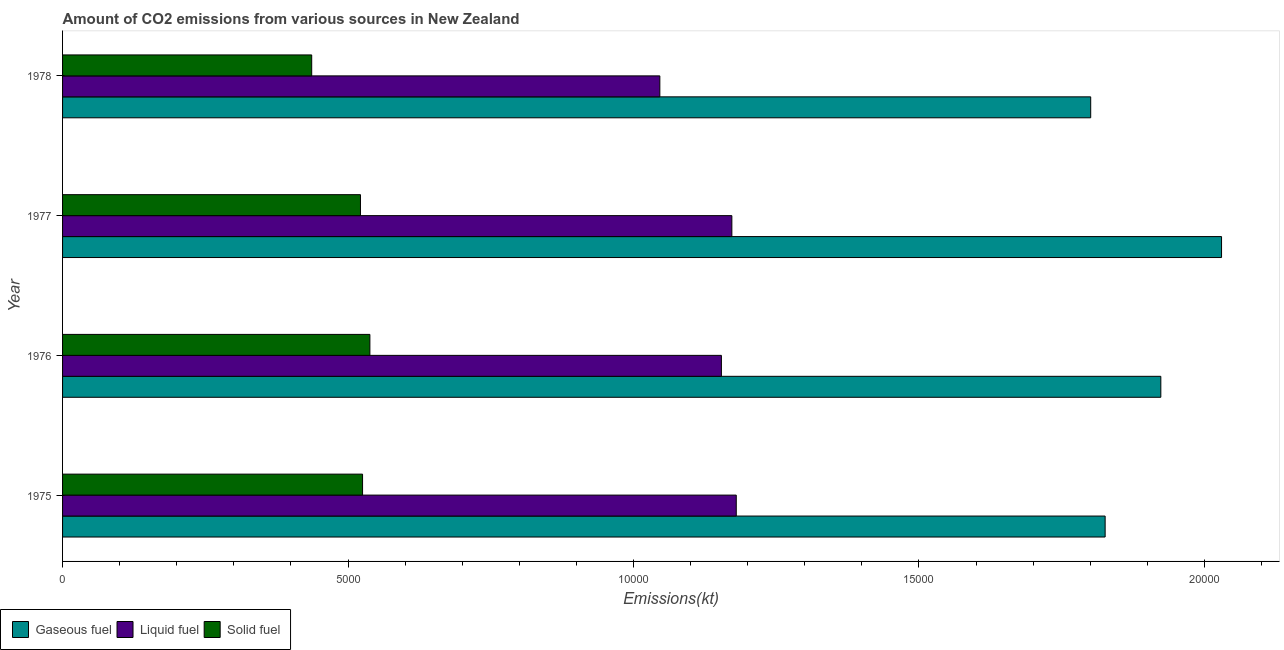How many different coloured bars are there?
Ensure brevity in your answer.  3. How many groups of bars are there?
Your answer should be compact. 4. Are the number of bars per tick equal to the number of legend labels?
Offer a terse response. Yes. What is the label of the 1st group of bars from the top?
Ensure brevity in your answer.  1978. What is the amount of co2 emissions from solid fuel in 1976?
Provide a short and direct response. 5383.16. Across all years, what is the maximum amount of co2 emissions from solid fuel?
Give a very brief answer. 5383.16. Across all years, what is the minimum amount of co2 emissions from liquid fuel?
Your answer should be very brief. 1.05e+04. In which year was the amount of co2 emissions from gaseous fuel maximum?
Keep it short and to the point. 1977. In which year was the amount of co2 emissions from gaseous fuel minimum?
Give a very brief answer. 1978. What is the total amount of co2 emissions from gaseous fuel in the graph?
Provide a succinct answer. 7.58e+04. What is the difference between the amount of co2 emissions from gaseous fuel in 1975 and that in 1976?
Offer a terse response. -975.42. What is the difference between the amount of co2 emissions from gaseous fuel in 1976 and the amount of co2 emissions from solid fuel in 1978?
Provide a succinct answer. 1.49e+04. What is the average amount of co2 emissions from gaseous fuel per year?
Your response must be concise. 1.90e+04. In the year 1977, what is the difference between the amount of co2 emissions from liquid fuel and amount of co2 emissions from gaseous fuel?
Provide a short and direct response. -8577.11. In how many years, is the amount of co2 emissions from gaseous fuel greater than 20000 kt?
Offer a very short reply. 1. What is the ratio of the amount of co2 emissions from liquid fuel in 1975 to that in 1978?
Make the answer very short. 1.13. Is the amount of co2 emissions from gaseous fuel in 1977 less than that in 1978?
Your answer should be compact. No. Is the difference between the amount of co2 emissions from gaseous fuel in 1977 and 1978 greater than the difference between the amount of co2 emissions from solid fuel in 1977 and 1978?
Your answer should be compact. Yes. What is the difference between the highest and the second highest amount of co2 emissions from solid fuel?
Provide a short and direct response. 128.34. What is the difference between the highest and the lowest amount of co2 emissions from solid fuel?
Give a very brief answer. 1019.43. In how many years, is the amount of co2 emissions from solid fuel greater than the average amount of co2 emissions from solid fuel taken over all years?
Your answer should be compact. 3. Is the sum of the amount of co2 emissions from gaseous fuel in 1976 and 1978 greater than the maximum amount of co2 emissions from liquid fuel across all years?
Make the answer very short. Yes. What does the 1st bar from the top in 1975 represents?
Your response must be concise. Solid fuel. What does the 1st bar from the bottom in 1975 represents?
Your answer should be compact. Gaseous fuel. How many years are there in the graph?
Make the answer very short. 4. Does the graph contain any zero values?
Give a very brief answer. No. Where does the legend appear in the graph?
Offer a terse response. Bottom left. How are the legend labels stacked?
Give a very brief answer. Horizontal. What is the title of the graph?
Your response must be concise. Amount of CO2 emissions from various sources in New Zealand. What is the label or title of the X-axis?
Your response must be concise. Emissions(kt). What is the Emissions(kt) in Gaseous fuel in 1975?
Offer a terse response. 1.83e+04. What is the Emissions(kt) in Liquid fuel in 1975?
Keep it short and to the point. 1.18e+04. What is the Emissions(kt) of Solid fuel in 1975?
Your answer should be compact. 5254.81. What is the Emissions(kt) of Gaseous fuel in 1976?
Offer a terse response. 1.92e+04. What is the Emissions(kt) of Liquid fuel in 1976?
Give a very brief answer. 1.15e+04. What is the Emissions(kt) in Solid fuel in 1976?
Keep it short and to the point. 5383.16. What is the Emissions(kt) of Gaseous fuel in 1977?
Provide a succinct answer. 2.03e+04. What is the Emissions(kt) of Liquid fuel in 1977?
Ensure brevity in your answer.  1.17e+04. What is the Emissions(kt) of Solid fuel in 1977?
Provide a short and direct response. 5218.14. What is the Emissions(kt) in Gaseous fuel in 1978?
Ensure brevity in your answer.  1.80e+04. What is the Emissions(kt) of Liquid fuel in 1978?
Offer a very short reply. 1.05e+04. What is the Emissions(kt) in Solid fuel in 1978?
Give a very brief answer. 4363.73. Across all years, what is the maximum Emissions(kt) of Gaseous fuel?
Offer a terse response. 2.03e+04. Across all years, what is the maximum Emissions(kt) of Liquid fuel?
Your answer should be very brief. 1.18e+04. Across all years, what is the maximum Emissions(kt) of Solid fuel?
Your response must be concise. 5383.16. Across all years, what is the minimum Emissions(kt) of Gaseous fuel?
Ensure brevity in your answer.  1.80e+04. Across all years, what is the minimum Emissions(kt) of Liquid fuel?
Offer a terse response. 1.05e+04. Across all years, what is the minimum Emissions(kt) in Solid fuel?
Your response must be concise. 4363.73. What is the total Emissions(kt) in Gaseous fuel in the graph?
Provide a short and direct response. 7.58e+04. What is the total Emissions(kt) of Liquid fuel in the graph?
Give a very brief answer. 4.55e+04. What is the total Emissions(kt) of Solid fuel in the graph?
Ensure brevity in your answer.  2.02e+04. What is the difference between the Emissions(kt) in Gaseous fuel in 1975 and that in 1976?
Give a very brief answer. -975.42. What is the difference between the Emissions(kt) in Liquid fuel in 1975 and that in 1976?
Your answer should be very brief. 260.36. What is the difference between the Emissions(kt) of Solid fuel in 1975 and that in 1976?
Provide a short and direct response. -128.34. What is the difference between the Emissions(kt) of Gaseous fuel in 1975 and that in 1977?
Offer a terse response. -2038.85. What is the difference between the Emissions(kt) of Liquid fuel in 1975 and that in 1977?
Offer a very short reply. 77.01. What is the difference between the Emissions(kt) in Solid fuel in 1975 and that in 1977?
Your answer should be very brief. 36.67. What is the difference between the Emissions(kt) of Gaseous fuel in 1975 and that in 1978?
Make the answer very short. 253.02. What is the difference between the Emissions(kt) of Liquid fuel in 1975 and that in 1978?
Keep it short and to the point. 1338.45. What is the difference between the Emissions(kt) in Solid fuel in 1975 and that in 1978?
Keep it short and to the point. 891.08. What is the difference between the Emissions(kt) in Gaseous fuel in 1976 and that in 1977?
Make the answer very short. -1063.43. What is the difference between the Emissions(kt) in Liquid fuel in 1976 and that in 1977?
Provide a short and direct response. -183.35. What is the difference between the Emissions(kt) of Solid fuel in 1976 and that in 1977?
Keep it short and to the point. 165.01. What is the difference between the Emissions(kt) of Gaseous fuel in 1976 and that in 1978?
Give a very brief answer. 1228.44. What is the difference between the Emissions(kt) of Liquid fuel in 1976 and that in 1978?
Keep it short and to the point. 1078.1. What is the difference between the Emissions(kt) of Solid fuel in 1976 and that in 1978?
Ensure brevity in your answer.  1019.43. What is the difference between the Emissions(kt) in Gaseous fuel in 1977 and that in 1978?
Give a very brief answer. 2291.88. What is the difference between the Emissions(kt) in Liquid fuel in 1977 and that in 1978?
Provide a short and direct response. 1261.45. What is the difference between the Emissions(kt) of Solid fuel in 1977 and that in 1978?
Your response must be concise. 854.41. What is the difference between the Emissions(kt) in Gaseous fuel in 1975 and the Emissions(kt) in Liquid fuel in 1976?
Give a very brief answer. 6721.61. What is the difference between the Emissions(kt) of Gaseous fuel in 1975 and the Emissions(kt) of Solid fuel in 1976?
Your response must be concise. 1.29e+04. What is the difference between the Emissions(kt) of Liquid fuel in 1975 and the Emissions(kt) of Solid fuel in 1976?
Ensure brevity in your answer.  6417.25. What is the difference between the Emissions(kt) of Gaseous fuel in 1975 and the Emissions(kt) of Liquid fuel in 1977?
Make the answer very short. 6538.26. What is the difference between the Emissions(kt) of Gaseous fuel in 1975 and the Emissions(kt) of Solid fuel in 1977?
Give a very brief answer. 1.30e+04. What is the difference between the Emissions(kt) of Liquid fuel in 1975 and the Emissions(kt) of Solid fuel in 1977?
Give a very brief answer. 6582.27. What is the difference between the Emissions(kt) of Gaseous fuel in 1975 and the Emissions(kt) of Liquid fuel in 1978?
Give a very brief answer. 7799.71. What is the difference between the Emissions(kt) of Gaseous fuel in 1975 and the Emissions(kt) of Solid fuel in 1978?
Offer a terse response. 1.39e+04. What is the difference between the Emissions(kt) of Liquid fuel in 1975 and the Emissions(kt) of Solid fuel in 1978?
Provide a short and direct response. 7436.68. What is the difference between the Emissions(kt) in Gaseous fuel in 1976 and the Emissions(kt) in Liquid fuel in 1977?
Ensure brevity in your answer.  7513.68. What is the difference between the Emissions(kt) in Gaseous fuel in 1976 and the Emissions(kt) in Solid fuel in 1977?
Provide a short and direct response. 1.40e+04. What is the difference between the Emissions(kt) of Liquid fuel in 1976 and the Emissions(kt) of Solid fuel in 1977?
Provide a succinct answer. 6321.91. What is the difference between the Emissions(kt) of Gaseous fuel in 1976 and the Emissions(kt) of Liquid fuel in 1978?
Your answer should be compact. 8775.13. What is the difference between the Emissions(kt) of Gaseous fuel in 1976 and the Emissions(kt) of Solid fuel in 1978?
Your response must be concise. 1.49e+04. What is the difference between the Emissions(kt) in Liquid fuel in 1976 and the Emissions(kt) in Solid fuel in 1978?
Give a very brief answer. 7176.32. What is the difference between the Emissions(kt) in Gaseous fuel in 1977 and the Emissions(kt) in Liquid fuel in 1978?
Keep it short and to the point. 9838.56. What is the difference between the Emissions(kt) in Gaseous fuel in 1977 and the Emissions(kt) in Solid fuel in 1978?
Give a very brief answer. 1.59e+04. What is the difference between the Emissions(kt) in Liquid fuel in 1977 and the Emissions(kt) in Solid fuel in 1978?
Keep it short and to the point. 7359.67. What is the average Emissions(kt) in Gaseous fuel per year?
Ensure brevity in your answer.  1.90e+04. What is the average Emissions(kt) in Liquid fuel per year?
Ensure brevity in your answer.  1.14e+04. What is the average Emissions(kt) in Solid fuel per year?
Provide a succinct answer. 5054.96. In the year 1975, what is the difference between the Emissions(kt) in Gaseous fuel and Emissions(kt) in Liquid fuel?
Provide a succinct answer. 6461.25. In the year 1975, what is the difference between the Emissions(kt) in Gaseous fuel and Emissions(kt) in Solid fuel?
Your answer should be compact. 1.30e+04. In the year 1975, what is the difference between the Emissions(kt) of Liquid fuel and Emissions(kt) of Solid fuel?
Keep it short and to the point. 6545.6. In the year 1976, what is the difference between the Emissions(kt) in Gaseous fuel and Emissions(kt) in Liquid fuel?
Keep it short and to the point. 7697.03. In the year 1976, what is the difference between the Emissions(kt) of Gaseous fuel and Emissions(kt) of Solid fuel?
Provide a short and direct response. 1.39e+04. In the year 1976, what is the difference between the Emissions(kt) in Liquid fuel and Emissions(kt) in Solid fuel?
Provide a short and direct response. 6156.89. In the year 1977, what is the difference between the Emissions(kt) in Gaseous fuel and Emissions(kt) in Liquid fuel?
Give a very brief answer. 8577.11. In the year 1977, what is the difference between the Emissions(kt) of Gaseous fuel and Emissions(kt) of Solid fuel?
Your answer should be very brief. 1.51e+04. In the year 1977, what is the difference between the Emissions(kt) of Liquid fuel and Emissions(kt) of Solid fuel?
Give a very brief answer. 6505.26. In the year 1978, what is the difference between the Emissions(kt) in Gaseous fuel and Emissions(kt) in Liquid fuel?
Provide a succinct answer. 7546.69. In the year 1978, what is the difference between the Emissions(kt) in Gaseous fuel and Emissions(kt) in Solid fuel?
Offer a very short reply. 1.36e+04. In the year 1978, what is the difference between the Emissions(kt) in Liquid fuel and Emissions(kt) in Solid fuel?
Your response must be concise. 6098.22. What is the ratio of the Emissions(kt) in Gaseous fuel in 1975 to that in 1976?
Ensure brevity in your answer.  0.95. What is the ratio of the Emissions(kt) in Liquid fuel in 1975 to that in 1976?
Provide a succinct answer. 1.02. What is the ratio of the Emissions(kt) in Solid fuel in 1975 to that in 1976?
Provide a succinct answer. 0.98. What is the ratio of the Emissions(kt) of Gaseous fuel in 1975 to that in 1977?
Provide a short and direct response. 0.9. What is the ratio of the Emissions(kt) in Liquid fuel in 1975 to that in 1977?
Give a very brief answer. 1.01. What is the ratio of the Emissions(kt) of Gaseous fuel in 1975 to that in 1978?
Make the answer very short. 1.01. What is the ratio of the Emissions(kt) in Liquid fuel in 1975 to that in 1978?
Give a very brief answer. 1.13. What is the ratio of the Emissions(kt) in Solid fuel in 1975 to that in 1978?
Keep it short and to the point. 1.2. What is the ratio of the Emissions(kt) in Gaseous fuel in 1976 to that in 1977?
Your response must be concise. 0.95. What is the ratio of the Emissions(kt) in Liquid fuel in 1976 to that in 1977?
Provide a short and direct response. 0.98. What is the ratio of the Emissions(kt) in Solid fuel in 1976 to that in 1977?
Your answer should be very brief. 1.03. What is the ratio of the Emissions(kt) in Gaseous fuel in 1976 to that in 1978?
Give a very brief answer. 1.07. What is the ratio of the Emissions(kt) of Liquid fuel in 1976 to that in 1978?
Offer a terse response. 1.1. What is the ratio of the Emissions(kt) in Solid fuel in 1976 to that in 1978?
Make the answer very short. 1.23. What is the ratio of the Emissions(kt) of Gaseous fuel in 1977 to that in 1978?
Offer a terse response. 1.13. What is the ratio of the Emissions(kt) of Liquid fuel in 1977 to that in 1978?
Your answer should be compact. 1.12. What is the ratio of the Emissions(kt) in Solid fuel in 1977 to that in 1978?
Provide a short and direct response. 1.2. What is the difference between the highest and the second highest Emissions(kt) of Gaseous fuel?
Your answer should be compact. 1063.43. What is the difference between the highest and the second highest Emissions(kt) of Liquid fuel?
Provide a short and direct response. 77.01. What is the difference between the highest and the second highest Emissions(kt) in Solid fuel?
Provide a short and direct response. 128.34. What is the difference between the highest and the lowest Emissions(kt) in Gaseous fuel?
Your answer should be compact. 2291.88. What is the difference between the highest and the lowest Emissions(kt) of Liquid fuel?
Your answer should be very brief. 1338.45. What is the difference between the highest and the lowest Emissions(kt) in Solid fuel?
Provide a short and direct response. 1019.43. 